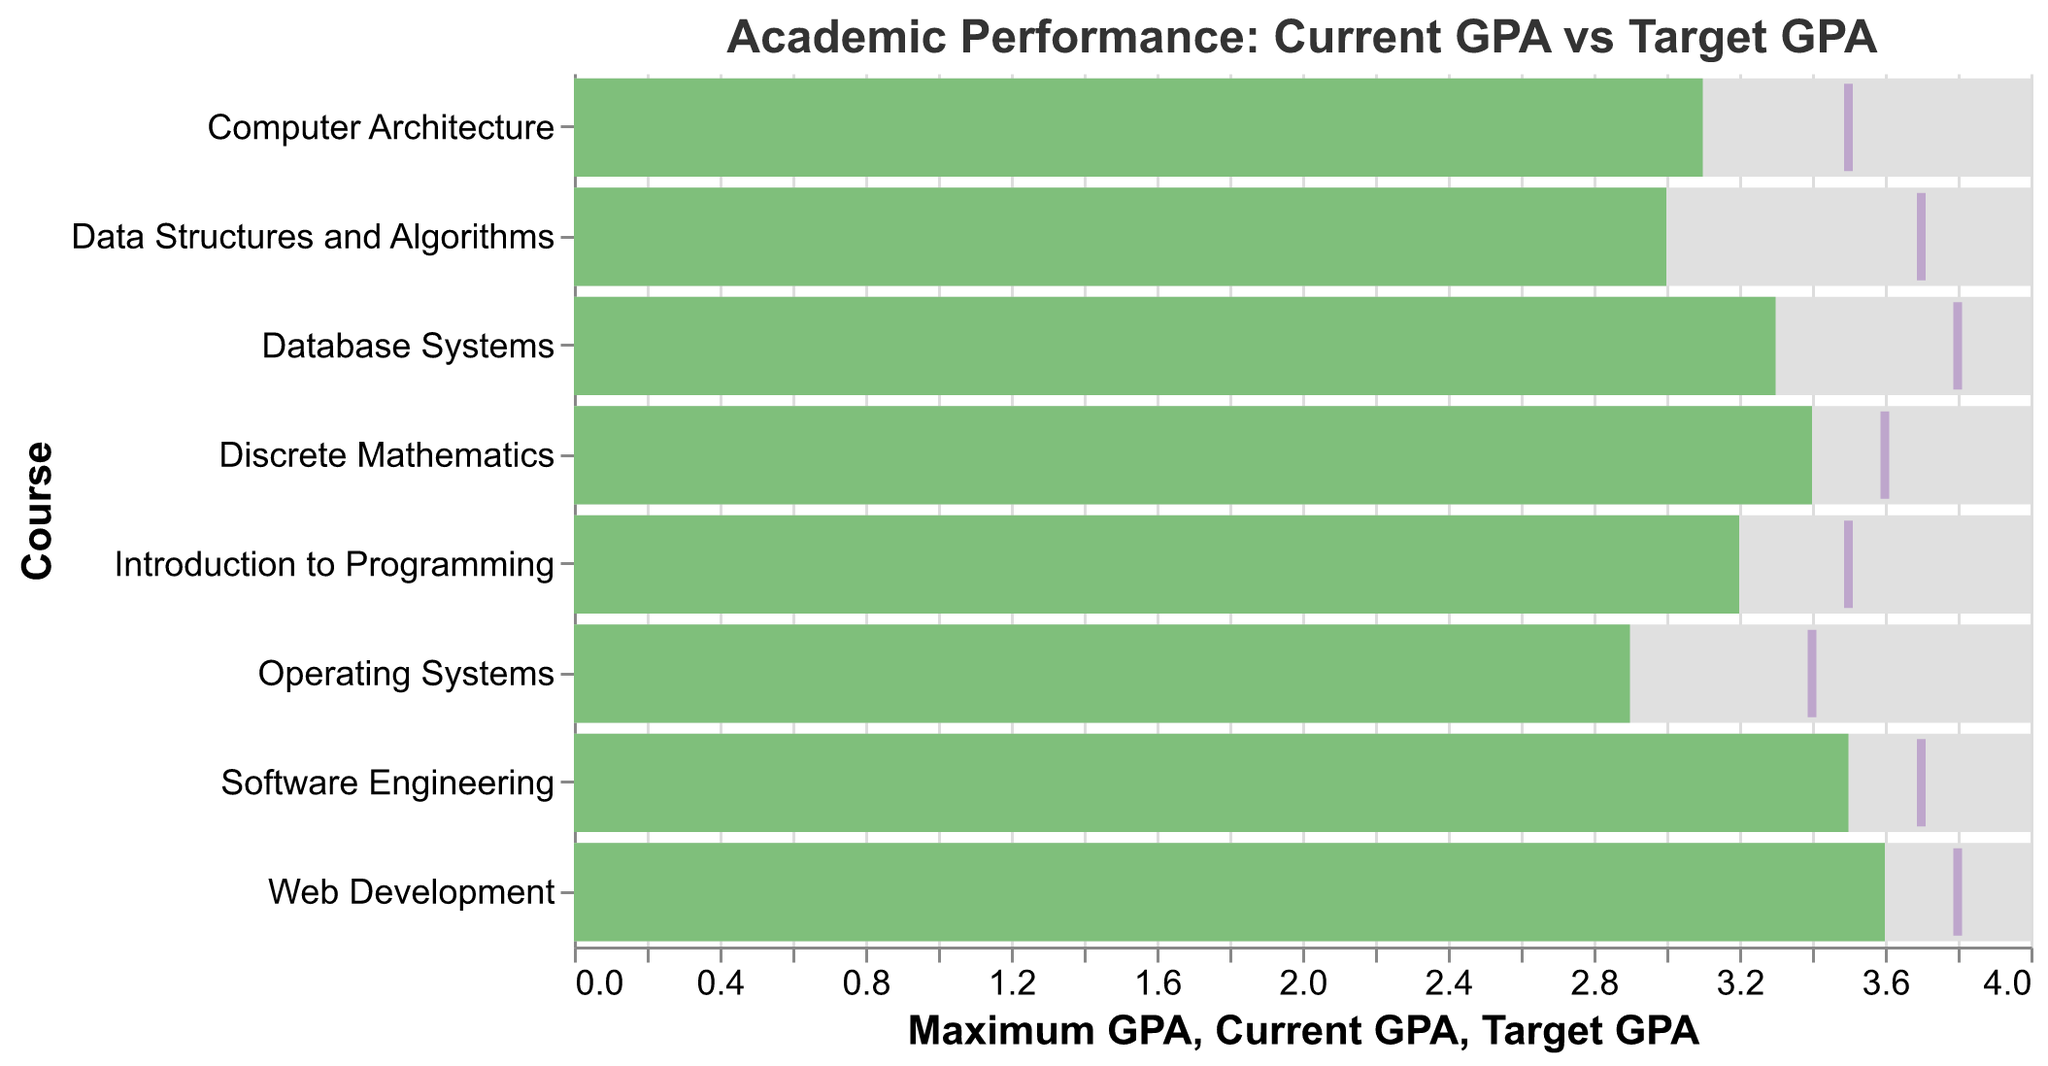**Question 1**
What is the title of the chart? The title is found at the top of the chart and provides context for what the visualization represents.
Answer: Academic Performance: Current GPA vs Target GPA **Question 2**
Which course has the highest current GPA? By looking at the green bars, which represent the current GPA, see which bar extends the furthest to the right.
Answer: Web Development **Question 3**
What are the three courses with the lowest current GPA? By comparing the green bars on the chart, identify the three shortest ones, corresponding to the lowest current GPAs.
Answer: Operating Systems, Data Structures and Algorithms, and Computer Architecture **Question 4**
How does the current GPA for ‘Operating Systems’ compare to its target GPA? Locate the green bar and the purple tick mark for ‘Operating Systems’ and compare their positions on the x-axis.
Answer: The current GPA (2.9) is lower than the target GPA (3.4) **Question 5**
Which course has the largest gap between current GPA and target GPA? Calculate the difference between the target GPA and the current GPA for each course and find the largest value.
Answer: Data Structures and Algorithms **Question 6**
Is there any course where the current GPA exceeds the target GPA? Compare the green bars (current GPA) and the tick marks (target GPA) to see if any green bar extends further to the right than its corresponding tick mark.
Answer: No **Question 7**
How many courses have a target GPA of 3.7 or above? Count the tick marks positioned at or beyond the 3.7 mark on the x-axis.
Answer: Four **Question 8**
What is the average current GPA across all courses? Find the sum of all current GPAs and divide by the number of courses. The sum is 3.2 + 3.0 + 3.4 + 3.1 + 3.3 + 2.9 + 3.5 + 3.6 = 26.0, and there are 8 courses.
Answer: 26.0 / 8 = 3.25 **Question 9**
Which course has the smallest gap between current GPA and target GPA? Calculate the difference between target GPA and current GPA for each course and identify the smallest value.
Answer: Discrete Mathematics **Question 10**
What is the difference between the highest target GPA and the lowest target GPA? Locate the highest and lowest values among the target GPAs and subtract the lowest from the highest. The highest is 3.8 (Database Systems and Web Development), and the lowest is 3.4 (Operating Systems).
Answer: 3.8 - 3.4 = 0.4 